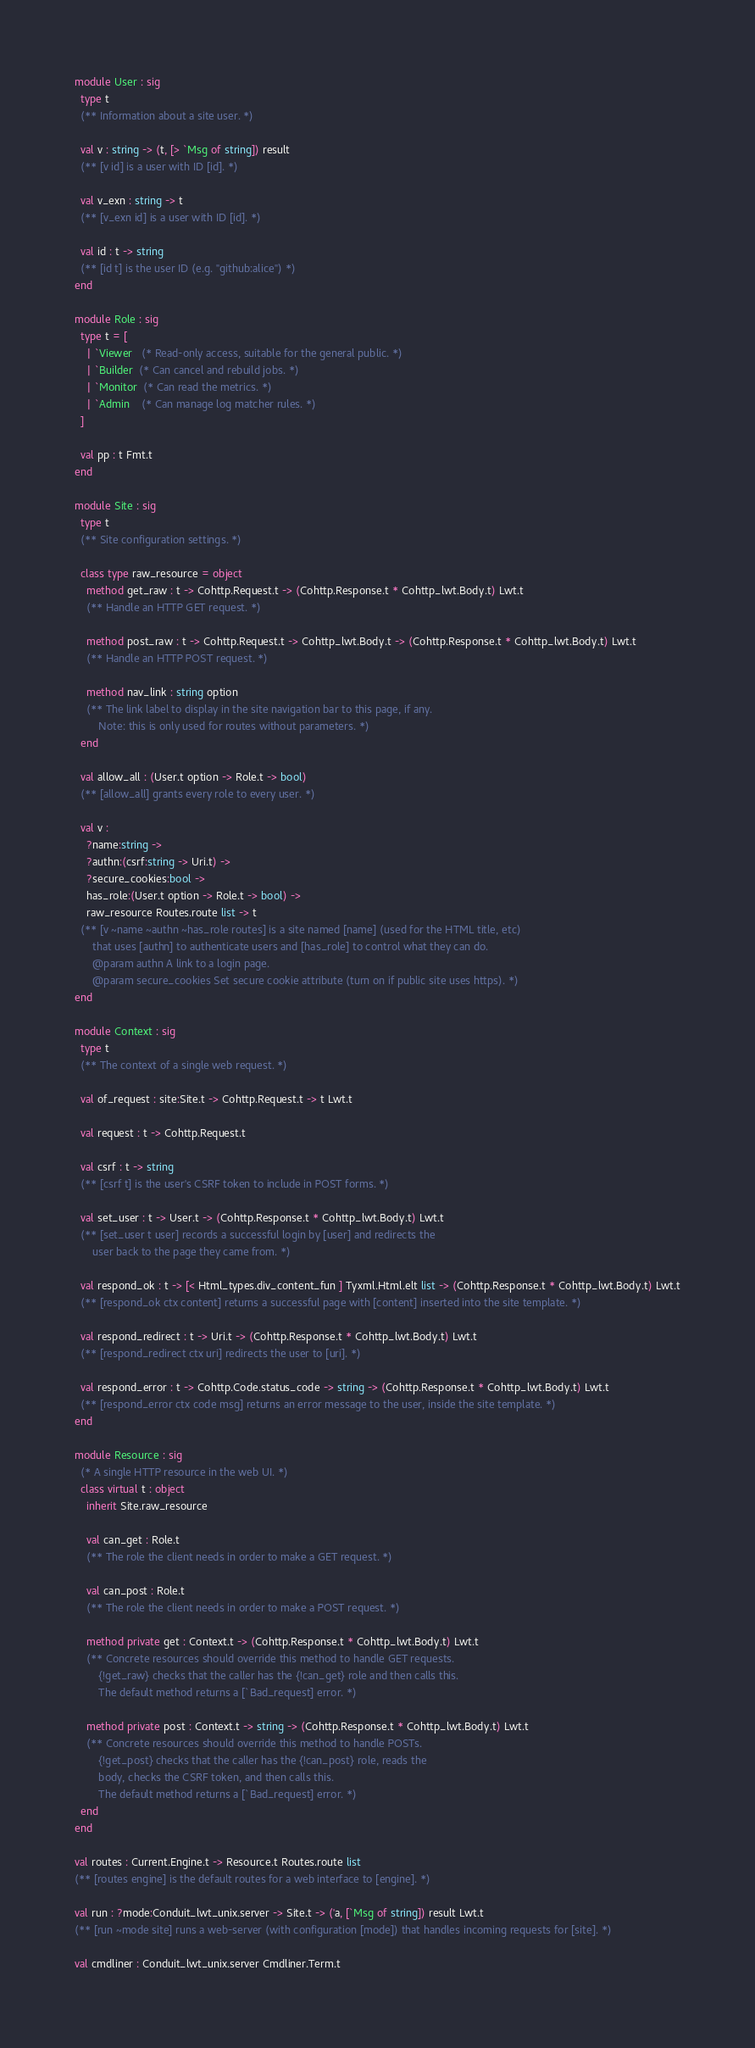Convert code to text. <code><loc_0><loc_0><loc_500><loc_500><_OCaml_>module User : sig
  type t
  (** Information about a site user. *)

  val v : string -> (t, [> `Msg of string]) result
  (** [v id] is a user with ID [id]. *)

  val v_exn : string -> t
  (** [v_exn id] is a user with ID [id]. *)

  val id : t -> string
  (** [id t] is the user ID (e.g. "github:alice") *)
end

module Role : sig
  type t = [
    | `Viewer   (* Read-only access, suitable for the general public. *)
    | `Builder  (* Can cancel and rebuild jobs. *)
    | `Monitor  (* Can read the metrics. *)
    | `Admin    (* Can manage log matcher rules. *)
  ]

  val pp : t Fmt.t
end

module Site : sig
  type t
  (** Site configuration settings. *)

  class type raw_resource = object
    method get_raw : t -> Cohttp.Request.t -> (Cohttp.Response.t * Cohttp_lwt.Body.t) Lwt.t
    (** Handle an HTTP GET request. *)

    method post_raw : t -> Cohttp.Request.t -> Cohttp_lwt.Body.t -> (Cohttp.Response.t * Cohttp_lwt.Body.t) Lwt.t
    (** Handle an HTTP POST request. *)

    method nav_link : string option
    (** The link label to display in the site navigation bar to this page, if any.
        Note: this is only used for routes without parameters. *)
  end

  val allow_all : (User.t option -> Role.t -> bool)
  (** [allow_all] grants every role to every user. *)

  val v :
    ?name:string ->
    ?authn:(csrf:string -> Uri.t) ->
    ?secure_cookies:bool ->
    has_role:(User.t option -> Role.t -> bool) ->
    raw_resource Routes.route list -> t
  (** [v ~name ~authn ~has_role routes] is a site named [name] (used for the HTML title, etc)
      that uses [authn] to authenticate users and [has_role] to control what they can do.
      @param authn A link to a login page.
      @param secure_cookies Set secure cookie attribute (turn on if public site uses https). *)
end

module Context : sig
  type t
  (** The context of a single web request. *)

  val of_request : site:Site.t -> Cohttp.Request.t -> t Lwt.t

  val request : t -> Cohttp.Request.t

  val csrf : t -> string
  (** [csrf t] is the user's CSRF token to include in POST forms. *)

  val set_user : t -> User.t -> (Cohttp.Response.t * Cohttp_lwt.Body.t) Lwt.t
  (** [set_user t user] records a successful login by [user] and redirects the
      user back to the page they came from. *)

  val respond_ok : t -> [< Html_types.div_content_fun ] Tyxml.Html.elt list -> (Cohttp.Response.t * Cohttp_lwt.Body.t) Lwt.t
  (** [respond_ok ctx content] returns a successful page with [content] inserted into the site template. *)

  val respond_redirect : t -> Uri.t -> (Cohttp.Response.t * Cohttp_lwt.Body.t) Lwt.t
  (** [respond_redirect ctx uri] redirects the user to [uri]. *)

  val respond_error : t -> Cohttp.Code.status_code -> string -> (Cohttp.Response.t * Cohttp_lwt.Body.t) Lwt.t
  (** [respond_error ctx code msg] returns an error message to the user, inside the site template. *)
end

module Resource : sig
  (* A single HTTP resource in the web UI. *)
  class virtual t : object
    inherit Site.raw_resource

    val can_get : Role.t
    (** The role the client needs in order to make a GET request. *)

    val can_post : Role.t
    (** The role the client needs in order to make a POST request. *)

    method private get : Context.t -> (Cohttp.Response.t * Cohttp_lwt.Body.t) Lwt.t
    (** Concrete resources should override this method to handle GET requests.
        {!get_raw} checks that the caller has the {!can_get} role and then calls this.
        The default method returns a [`Bad_request] error. *)

    method private post : Context.t -> string -> (Cohttp.Response.t * Cohttp_lwt.Body.t) Lwt.t
    (** Concrete resources should override this method to handle POSTs.
        {!get_post} checks that the caller has the {!can_post} role, reads the
        body, checks the CSRF token, and then calls this.
        The default method returns a [`Bad_request] error. *)
  end
end

val routes : Current.Engine.t -> Resource.t Routes.route list
(** [routes engine] is the default routes for a web interface to [engine]. *)

val run : ?mode:Conduit_lwt_unix.server -> Site.t -> ('a, [`Msg of string]) result Lwt.t
(** [run ~mode site] runs a web-server (with configuration [mode]) that handles incoming requests for [site]. *)

val cmdliner : Conduit_lwt_unix.server Cmdliner.Term.t
</code> 